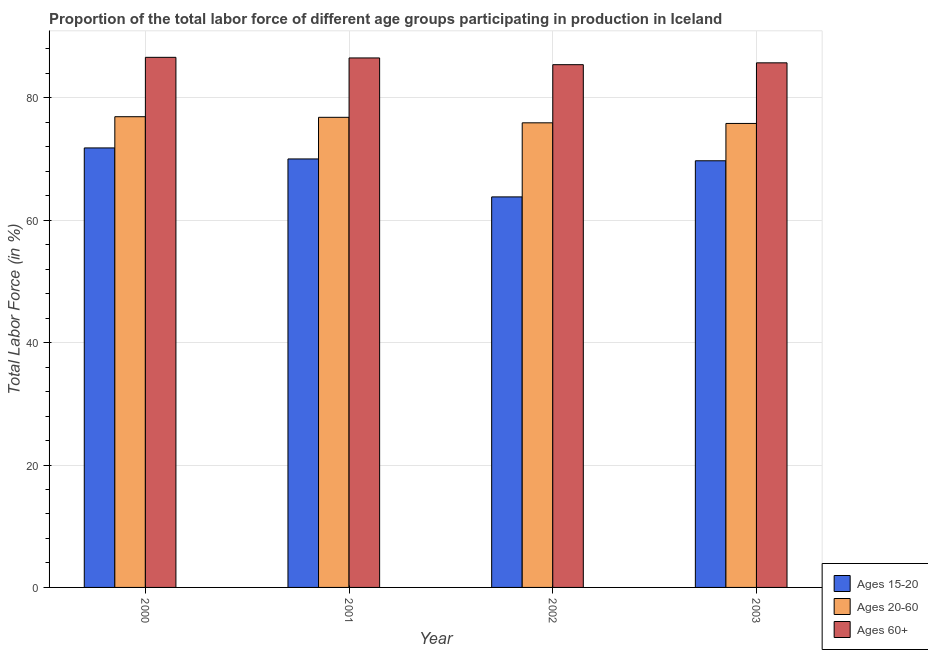Are the number of bars per tick equal to the number of legend labels?
Keep it short and to the point. Yes. How many bars are there on the 4th tick from the left?
Keep it short and to the point. 3. In how many cases, is the number of bars for a given year not equal to the number of legend labels?
Offer a terse response. 0. What is the percentage of labor force above age 60 in 2000?
Your answer should be very brief. 86.6. Across all years, what is the maximum percentage of labor force within the age group 15-20?
Your answer should be compact. 71.8. Across all years, what is the minimum percentage of labor force above age 60?
Your response must be concise. 85.4. What is the total percentage of labor force within the age group 15-20 in the graph?
Your answer should be very brief. 275.3. What is the difference between the percentage of labor force above age 60 in 2000 and that in 2003?
Ensure brevity in your answer.  0.9. What is the difference between the percentage of labor force above age 60 in 2000 and the percentage of labor force within the age group 15-20 in 2003?
Make the answer very short. 0.9. What is the average percentage of labor force within the age group 20-60 per year?
Keep it short and to the point. 76.35. In the year 2002, what is the difference between the percentage of labor force within the age group 20-60 and percentage of labor force above age 60?
Make the answer very short. 0. What is the ratio of the percentage of labor force within the age group 15-20 in 2000 to that in 2001?
Keep it short and to the point. 1.03. What is the difference between the highest and the second highest percentage of labor force within the age group 15-20?
Your response must be concise. 1.8. What is the difference between the highest and the lowest percentage of labor force within the age group 15-20?
Provide a short and direct response. 8. In how many years, is the percentage of labor force within the age group 15-20 greater than the average percentage of labor force within the age group 15-20 taken over all years?
Your response must be concise. 3. What does the 2nd bar from the left in 2002 represents?
Your answer should be very brief. Ages 20-60. What does the 2nd bar from the right in 2002 represents?
Your answer should be compact. Ages 20-60. Is it the case that in every year, the sum of the percentage of labor force within the age group 15-20 and percentage of labor force within the age group 20-60 is greater than the percentage of labor force above age 60?
Give a very brief answer. Yes. Are all the bars in the graph horizontal?
Give a very brief answer. No. Where does the legend appear in the graph?
Provide a short and direct response. Bottom right. How are the legend labels stacked?
Offer a very short reply. Vertical. What is the title of the graph?
Give a very brief answer. Proportion of the total labor force of different age groups participating in production in Iceland. What is the label or title of the X-axis?
Provide a short and direct response. Year. What is the label or title of the Y-axis?
Ensure brevity in your answer.  Total Labor Force (in %). What is the Total Labor Force (in %) in Ages 15-20 in 2000?
Give a very brief answer. 71.8. What is the Total Labor Force (in %) in Ages 20-60 in 2000?
Keep it short and to the point. 76.9. What is the Total Labor Force (in %) of Ages 60+ in 2000?
Offer a terse response. 86.6. What is the Total Labor Force (in %) of Ages 15-20 in 2001?
Offer a very short reply. 70. What is the Total Labor Force (in %) in Ages 20-60 in 2001?
Your answer should be very brief. 76.8. What is the Total Labor Force (in %) in Ages 60+ in 2001?
Keep it short and to the point. 86.5. What is the Total Labor Force (in %) of Ages 15-20 in 2002?
Offer a terse response. 63.8. What is the Total Labor Force (in %) of Ages 20-60 in 2002?
Keep it short and to the point. 75.9. What is the Total Labor Force (in %) in Ages 60+ in 2002?
Offer a very short reply. 85.4. What is the Total Labor Force (in %) of Ages 15-20 in 2003?
Provide a succinct answer. 69.7. What is the Total Labor Force (in %) in Ages 20-60 in 2003?
Offer a very short reply. 75.8. What is the Total Labor Force (in %) in Ages 60+ in 2003?
Provide a succinct answer. 85.7. Across all years, what is the maximum Total Labor Force (in %) of Ages 15-20?
Your answer should be very brief. 71.8. Across all years, what is the maximum Total Labor Force (in %) in Ages 20-60?
Keep it short and to the point. 76.9. Across all years, what is the maximum Total Labor Force (in %) in Ages 60+?
Offer a terse response. 86.6. Across all years, what is the minimum Total Labor Force (in %) in Ages 15-20?
Make the answer very short. 63.8. Across all years, what is the minimum Total Labor Force (in %) of Ages 20-60?
Give a very brief answer. 75.8. Across all years, what is the minimum Total Labor Force (in %) of Ages 60+?
Provide a succinct answer. 85.4. What is the total Total Labor Force (in %) of Ages 15-20 in the graph?
Give a very brief answer. 275.3. What is the total Total Labor Force (in %) of Ages 20-60 in the graph?
Provide a succinct answer. 305.4. What is the total Total Labor Force (in %) in Ages 60+ in the graph?
Ensure brevity in your answer.  344.2. What is the difference between the Total Labor Force (in %) in Ages 15-20 in 2000 and that in 2001?
Your answer should be compact. 1.8. What is the difference between the Total Labor Force (in %) of Ages 20-60 in 2000 and that in 2001?
Your response must be concise. 0.1. What is the difference between the Total Labor Force (in %) in Ages 20-60 in 2000 and that in 2002?
Ensure brevity in your answer.  1. What is the difference between the Total Labor Force (in %) in Ages 15-20 in 2000 and that in 2003?
Offer a terse response. 2.1. What is the difference between the Total Labor Force (in %) of Ages 20-60 in 2001 and that in 2002?
Offer a terse response. 0.9. What is the difference between the Total Labor Force (in %) of Ages 20-60 in 2001 and that in 2003?
Offer a terse response. 1. What is the difference between the Total Labor Force (in %) of Ages 60+ in 2001 and that in 2003?
Offer a terse response. 0.8. What is the difference between the Total Labor Force (in %) in Ages 15-20 in 2000 and the Total Labor Force (in %) in Ages 60+ in 2001?
Your response must be concise. -14.7. What is the difference between the Total Labor Force (in %) of Ages 15-20 in 2000 and the Total Labor Force (in %) of Ages 20-60 in 2002?
Keep it short and to the point. -4.1. What is the difference between the Total Labor Force (in %) of Ages 15-20 in 2000 and the Total Labor Force (in %) of Ages 60+ in 2002?
Keep it short and to the point. -13.6. What is the difference between the Total Labor Force (in %) of Ages 20-60 in 2000 and the Total Labor Force (in %) of Ages 60+ in 2002?
Make the answer very short. -8.5. What is the difference between the Total Labor Force (in %) in Ages 15-20 in 2000 and the Total Labor Force (in %) in Ages 20-60 in 2003?
Ensure brevity in your answer.  -4. What is the difference between the Total Labor Force (in %) of Ages 15-20 in 2000 and the Total Labor Force (in %) of Ages 60+ in 2003?
Ensure brevity in your answer.  -13.9. What is the difference between the Total Labor Force (in %) in Ages 15-20 in 2001 and the Total Labor Force (in %) in Ages 20-60 in 2002?
Offer a very short reply. -5.9. What is the difference between the Total Labor Force (in %) of Ages 15-20 in 2001 and the Total Labor Force (in %) of Ages 60+ in 2002?
Make the answer very short. -15.4. What is the difference between the Total Labor Force (in %) in Ages 15-20 in 2001 and the Total Labor Force (in %) in Ages 20-60 in 2003?
Give a very brief answer. -5.8. What is the difference between the Total Labor Force (in %) of Ages 15-20 in 2001 and the Total Labor Force (in %) of Ages 60+ in 2003?
Offer a very short reply. -15.7. What is the difference between the Total Labor Force (in %) of Ages 15-20 in 2002 and the Total Labor Force (in %) of Ages 60+ in 2003?
Give a very brief answer. -21.9. What is the average Total Labor Force (in %) in Ages 15-20 per year?
Offer a very short reply. 68.83. What is the average Total Labor Force (in %) in Ages 20-60 per year?
Your response must be concise. 76.35. What is the average Total Labor Force (in %) in Ages 60+ per year?
Your answer should be compact. 86.05. In the year 2000, what is the difference between the Total Labor Force (in %) in Ages 15-20 and Total Labor Force (in %) in Ages 20-60?
Make the answer very short. -5.1. In the year 2000, what is the difference between the Total Labor Force (in %) of Ages 15-20 and Total Labor Force (in %) of Ages 60+?
Make the answer very short. -14.8. In the year 2001, what is the difference between the Total Labor Force (in %) of Ages 15-20 and Total Labor Force (in %) of Ages 20-60?
Make the answer very short. -6.8. In the year 2001, what is the difference between the Total Labor Force (in %) in Ages 15-20 and Total Labor Force (in %) in Ages 60+?
Give a very brief answer. -16.5. In the year 2002, what is the difference between the Total Labor Force (in %) of Ages 15-20 and Total Labor Force (in %) of Ages 20-60?
Offer a very short reply. -12.1. In the year 2002, what is the difference between the Total Labor Force (in %) of Ages 15-20 and Total Labor Force (in %) of Ages 60+?
Offer a very short reply. -21.6. In the year 2003, what is the difference between the Total Labor Force (in %) of Ages 15-20 and Total Labor Force (in %) of Ages 60+?
Your response must be concise. -16. In the year 2003, what is the difference between the Total Labor Force (in %) in Ages 20-60 and Total Labor Force (in %) in Ages 60+?
Offer a terse response. -9.9. What is the ratio of the Total Labor Force (in %) in Ages 15-20 in 2000 to that in 2001?
Offer a terse response. 1.03. What is the ratio of the Total Labor Force (in %) in Ages 15-20 in 2000 to that in 2002?
Ensure brevity in your answer.  1.13. What is the ratio of the Total Labor Force (in %) of Ages 20-60 in 2000 to that in 2002?
Provide a succinct answer. 1.01. What is the ratio of the Total Labor Force (in %) in Ages 60+ in 2000 to that in 2002?
Make the answer very short. 1.01. What is the ratio of the Total Labor Force (in %) in Ages 15-20 in 2000 to that in 2003?
Make the answer very short. 1.03. What is the ratio of the Total Labor Force (in %) of Ages 20-60 in 2000 to that in 2003?
Offer a very short reply. 1.01. What is the ratio of the Total Labor Force (in %) of Ages 60+ in 2000 to that in 2003?
Keep it short and to the point. 1.01. What is the ratio of the Total Labor Force (in %) in Ages 15-20 in 2001 to that in 2002?
Provide a succinct answer. 1.1. What is the ratio of the Total Labor Force (in %) of Ages 20-60 in 2001 to that in 2002?
Your response must be concise. 1.01. What is the ratio of the Total Labor Force (in %) in Ages 60+ in 2001 to that in 2002?
Give a very brief answer. 1.01. What is the ratio of the Total Labor Force (in %) in Ages 20-60 in 2001 to that in 2003?
Your answer should be compact. 1.01. What is the ratio of the Total Labor Force (in %) of Ages 60+ in 2001 to that in 2003?
Offer a terse response. 1.01. What is the ratio of the Total Labor Force (in %) of Ages 15-20 in 2002 to that in 2003?
Keep it short and to the point. 0.92. What is the ratio of the Total Labor Force (in %) in Ages 60+ in 2002 to that in 2003?
Offer a terse response. 1. What is the difference between the highest and the second highest Total Labor Force (in %) in Ages 20-60?
Provide a short and direct response. 0.1. 